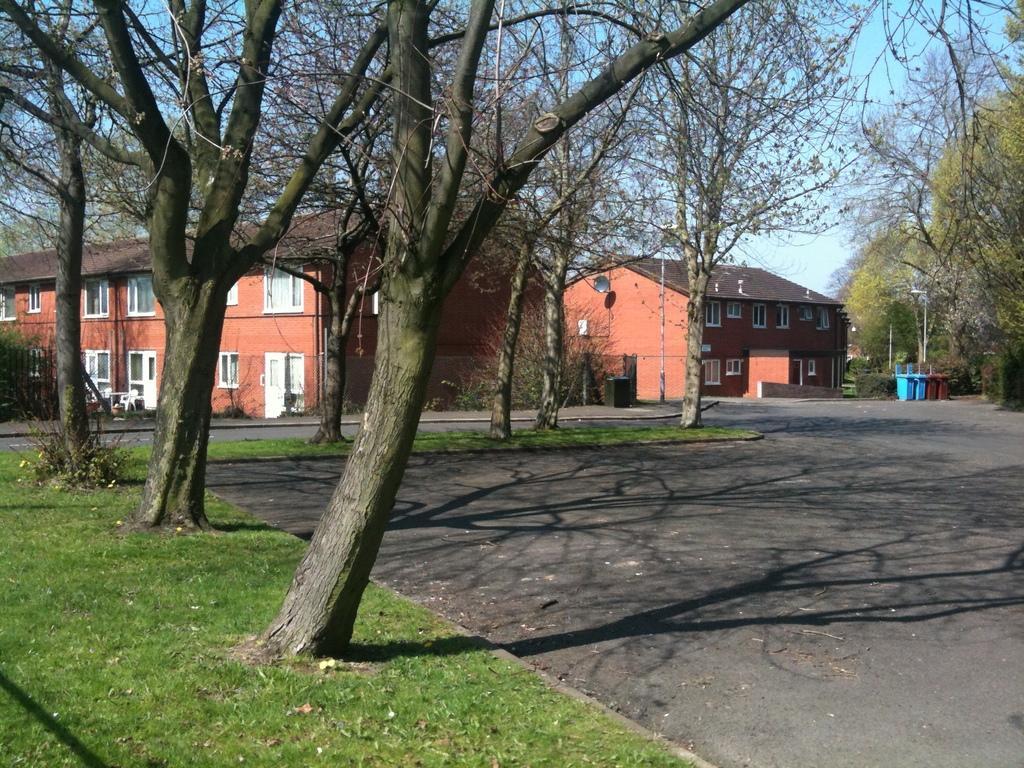Please provide a concise description of this image. In this image we can see the buildings. In front of the buildings we can see trees and the grass. On the right side, we can see dustbins and trees. At the top we can see the sky. 